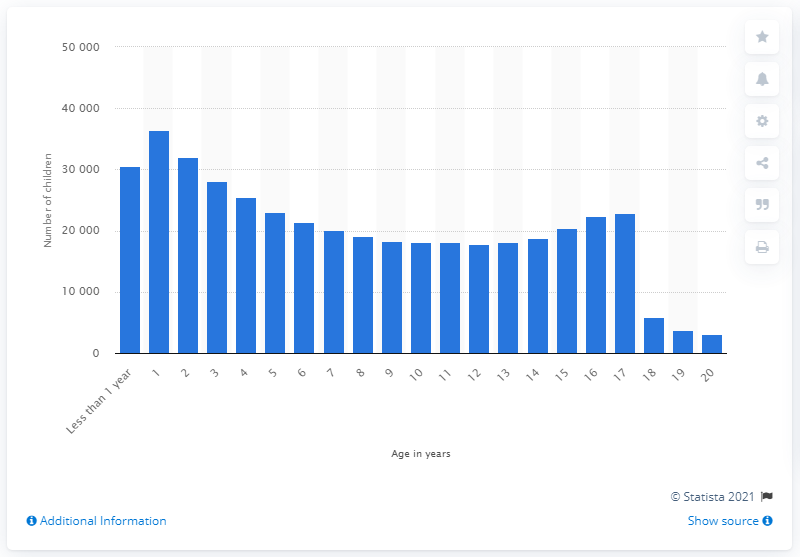Indicate a few pertinent items in this graphic. In 2019, the children in foster care were, on average, 17 years old. 